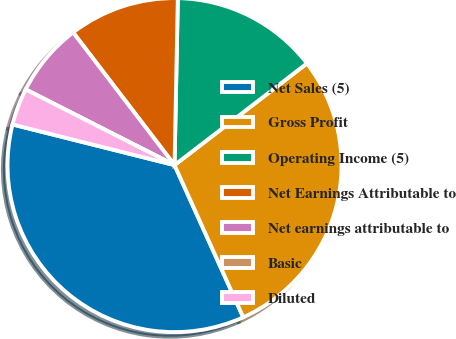<chart> <loc_0><loc_0><loc_500><loc_500><pie_chart><fcel>Net Sales (5)<fcel>Gross Profit<fcel>Operating Income (5)<fcel>Net Earnings Attributable to<fcel>Net earnings attributable to<fcel>Basic<fcel>Diluted<nl><fcel>35.66%<fcel>28.67%<fcel>14.26%<fcel>10.7%<fcel>7.13%<fcel>0.0%<fcel>3.57%<nl></chart> 